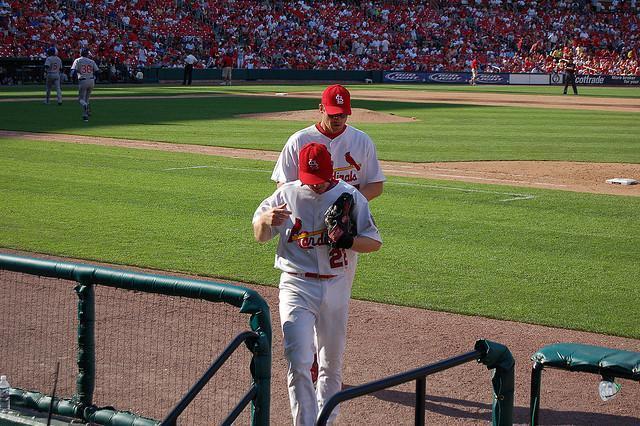At which location are the Cardinals playing?
Make your selection from the four choices given to correctly answer the question.
Options: Home field, wrigley, dodger stadium, shea. Home field. 